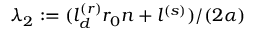Convert formula to latex. <formula><loc_0><loc_0><loc_500><loc_500>\lambda _ { 2 } \colon = ( l _ { d } ^ { ( r ) } r _ { 0 } n + l ^ { ( s ) } ) / ( 2 \alpha )</formula> 